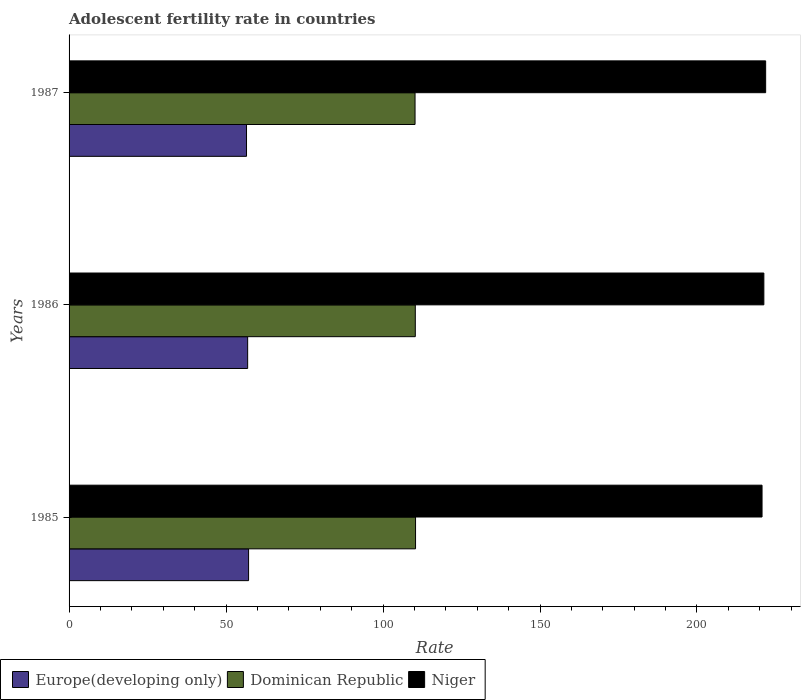How many groups of bars are there?
Make the answer very short. 3. Are the number of bars on each tick of the Y-axis equal?
Make the answer very short. Yes. How many bars are there on the 1st tick from the top?
Provide a succinct answer. 3. What is the adolescent fertility rate in Niger in 1987?
Make the answer very short. 221.88. Across all years, what is the maximum adolescent fertility rate in Dominican Republic?
Your answer should be very brief. 110.36. Across all years, what is the minimum adolescent fertility rate in Europe(developing only)?
Your answer should be compact. 56.52. In which year was the adolescent fertility rate in Europe(developing only) maximum?
Your answer should be compact. 1985. What is the total adolescent fertility rate in Europe(developing only) in the graph?
Provide a short and direct response. 170.58. What is the difference between the adolescent fertility rate in Dominican Republic in 1985 and that in 1987?
Give a very brief answer. 0.16. What is the difference between the adolescent fertility rate in Europe(developing only) in 1987 and the adolescent fertility rate in Niger in 1985?
Provide a succinct answer. -164.21. What is the average adolescent fertility rate in Niger per year?
Give a very brief answer. 221.3. In the year 1986, what is the difference between the adolescent fertility rate in Niger and adolescent fertility rate in Europe(developing only)?
Keep it short and to the point. 164.42. In how many years, is the adolescent fertility rate in Europe(developing only) greater than 200 ?
Provide a succinct answer. 0. What is the ratio of the adolescent fertility rate in Dominican Republic in 1985 to that in 1986?
Your answer should be compact. 1. Is the adolescent fertility rate in Dominican Republic in 1985 less than that in 1986?
Your response must be concise. No. What is the difference between the highest and the second highest adolescent fertility rate in Dominican Republic?
Your response must be concise. 0.08. What is the difference between the highest and the lowest adolescent fertility rate in Europe(developing only)?
Provide a short and direct response. 0.66. Is the sum of the adolescent fertility rate in Niger in 1985 and 1986 greater than the maximum adolescent fertility rate in Dominican Republic across all years?
Your answer should be very brief. Yes. What does the 2nd bar from the top in 1986 represents?
Offer a terse response. Dominican Republic. What does the 1st bar from the bottom in 1986 represents?
Provide a succinct answer. Europe(developing only). How many bars are there?
Offer a terse response. 9. Are all the bars in the graph horizontal?
Offer a very short reply. Yes. How many years are there in the graph?
Keep it short and to the point. 3. Are the values on the major ticks of X-axis written in scientific E-notation?
Your answer should be very brief. No. Does the graph contain any zero values?
Your response must be concise. No. Does the graph contain grids?
Your response must be concise. No. What is the title of the graph?
Make the answer very short. Adolescent fertility rate in countries. What is the label or title of the X-axis?
Offer a terse response. Rate. What is the label or title of the Y-axis?
Ensure brevity in your answer.  Years. What is the Rate of Europe(developing only) in 1985?
Your answer should be compact. 57.18. What is the Rate of Dominican Republic in 1985?
Your answer should be very brief. 110.36. What is the Rate of Niger in 1985?
Make the answer very short. 220.73. What is the Rate in Europe(developing only) in 1986?
Give a very brief answer. 56.88. What is the Rate in Dominican Republic in 1986?
Give a very brief answer. 110.28. What is the Rate of Niger in 1986?
Provide a short and direct response. 221.3. What is the Rate of Europe(developing only) in 1987?
Your answer should be very brief. 56.52. What is the Rate in Dominican Republic in 1987?
Offer a terse response. 110.2. What is the Rate in Niger in 1987?
Keep it short and to the point. 221.88. Across all years, what is the maximum Rate in Europe(developing only)?
Make the answer very short. 57.18. Across all years, what is the maximum Rate in Dominican Republic?
Provide a short and direct response. 110.36. Across all years, what is the maximum Rate in Niger?
Ensure brevity in your answer.  221.88. Across all years, what is the minimum Rate in Europe(developing only)?
Your answer should be very brief. 56.52. Across all years, what is the minimum Rate in Dominican Republic?
Ensure brevity in your answer.  110.2. Across all years, what is the minimum Rate in Niger?
Offer a terse response. 220.73. What is the total Rate of Europe(developing only) in the graph?
Provide a succinct answer. 170.58. What is the total Rate of Dominican Republic in the graph?
Offer a very short reply. 330.84. What is the total Rate of Niger in the graph?
Give a very brief answer. 663.91. What is the difference between the Rate of Europe(developing only) in 1985 and that in 1986?
Offer a very short reply. 0.29. What is the difference between the Rate in Dominican Republic in 1985 and that in 1986?
Your answer should be very brief. 0.08. What is the difference between the Rate of Niger in 1985 and that in 1986?
Make the answer very short. -0.58. What is the difference between the Rate of Europe(developing only) in 1985 and that in 1987?
Your answer should be very brief. 0.66. What is the difference between the Rate of Dominican Republic in 1985 and that in 1987?
Ensure brevity in your answer.  0.16. What is the difference between the Rate in Niger in 1985 and that in 1987?
Provide a succinct answer. -1.15. What is the difference between the Rate in Europe(developing only) in 1986 and that in 1987?
Your answer should be very brief. 0.37. What is the difference between the Rate of Dominican Republic in 1986 and that in 1987?
Provide a succinct answer. 0.08. What is the difference between the Rate in Niger in 1986 and that in 1987?
Provide a short and direct response. -0.58. What is the difference between the Rate of Europe(developing only) in 1985 and the Rate of Dominican Republic in 1986?
Make the answer very short. -53.1. What is the difference between the Rate in Europe(developing only) in 1985 and the Rate in Niger in 1986?
Offer a very short reply. -164.13. What is the difference between the Rate of Dominican Republic in 1985 and the Rate of Niger in 1986?
Provide a succinct answer. -110.95. What is the difference between the Rate of Europe(developing only) in 1985 and the Rate of Dominican Republic in 1987?
Provide a succinct answer. -53.02. What is the difference between the Rate of Europe(developing only) in 1985 and the Rate of Niger in 1987?
Provide a short and direct response. -164.7. What is the difference between the Rate of Dominican Republic in 1985 and the Rate of Niger in 1987?
Ensure brevity in your answer.  -111.52. What is the difference between the Rate in Europe(developing only) in 1986 and the Rate in Dominican Republic in 1987?
Your answer should be very brief. -53.32. What is the difference between the Rate in Europe(developing only) in 1986 and the Rate in Niger in 1987?
Keep it short and to the point. -165. What is the difference between the Rate of Dominican Republic in 1986 and the Rate of Niger in 1987?
Offer a very short reply. -111.6. What is the average Rate in Europe(developing only) per year?
Ensure brevity in your answer.  56.86. What is the average Rate of Dominican Republic per year?
Offer a terse response. 110.28. What is the average Rate of Niger per year?
Ensure brevity in your answer.  221.3. In the year 1985, what is the difference between the Rate of Europe(developing only) and Rate of Dominican Republic?
Give a very brief answer. -53.18. In the year 1985, what is the difference between the Rate of Europe(developing only) and Rate of Niger?
Ensure brevity in your answer.  -163.55. In the year 1985, what is the difference between the Rate in Dominican Republic and Rate in Niger?
Give a very brief answer. -110.37. In the year 1986, what is the difference between the Rate in Europe(developing only) and Rate in Dominican Republic?
Provide a succinct answer. -53.39. In the year 1986, what is the difference between the Rate in Europe(developing only) and Rate in Niger?
Ensure brevity in your answer.  -164.42. In the year 1986, what is the difference between the Rate in Dominican Republic and Rate in Niger?
Provide a succinct answer. -111.02. In the year 1987, what is the difference between the Rate in Europe(developing only) and Rate in Dominican Republic?
Offer a very short reply. -53.68. In the year 1987, what is the difference between the Rate in Europe(developing only) and Rate in Niger?
Your answer should be compact. -165.36. In the year 1987, what is the difference between the Rate in Dominican Republic and Rate in Niger?
Keep it short and to the point. -111.68. What is the ratio of the Rate of Dominican Republic in 1985 to that in 1986?
Offer a very short reply. 1. What is the ratio of the Rate of Europe(developing only) in 1985 to that in 1987?
Your response must be concise. 1.01. What is the ratio of the Rate in Niger in 1985 to that in 1987?
Your answer should be very brief. 0.99. What is the ratio of the Rate in Europe(developing only) in 1986 to that in 1987?
Your response must be concise. 1.01. What is the ratio of the Rate of Dominican Republic in 1986 to that in 1987?
Provide a short and direct response. 1. What is the ratio of the Rate in Niger in 1986 to that in 1987?
Keep it short and to the point. 1. What is the difference between the highest and the second highest Rate of Europe(developing only)?
Keep it short and to the point. 0.29. What is the difference between the highest and the second highest Rate of Dominican Republic?
Offer a very short reply. 0.08. What is the difference between the highest and the second highest Rate in Niger?
Ensure brevity in your answer.  0.58. What is the difference between the highest and the lowest Rate of Europe(developing only)?
Provide a succinct answer. 0.66. What is the difference between the highest and the lowest Rate in Dominican Republic?
Your response must be concise. 0.16. What is the difference between the highest and the lowest Rate in Niger?
Your answer should be very brief. 1.15. 